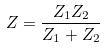Convert formula to latex. <formula><loc_0><loc_0><loc_500><loc_500>Z = \frac { Z _ { 1 } Z _ { 2 } } { Z _ { 1 } + Z _ { 2 } }</formula> 